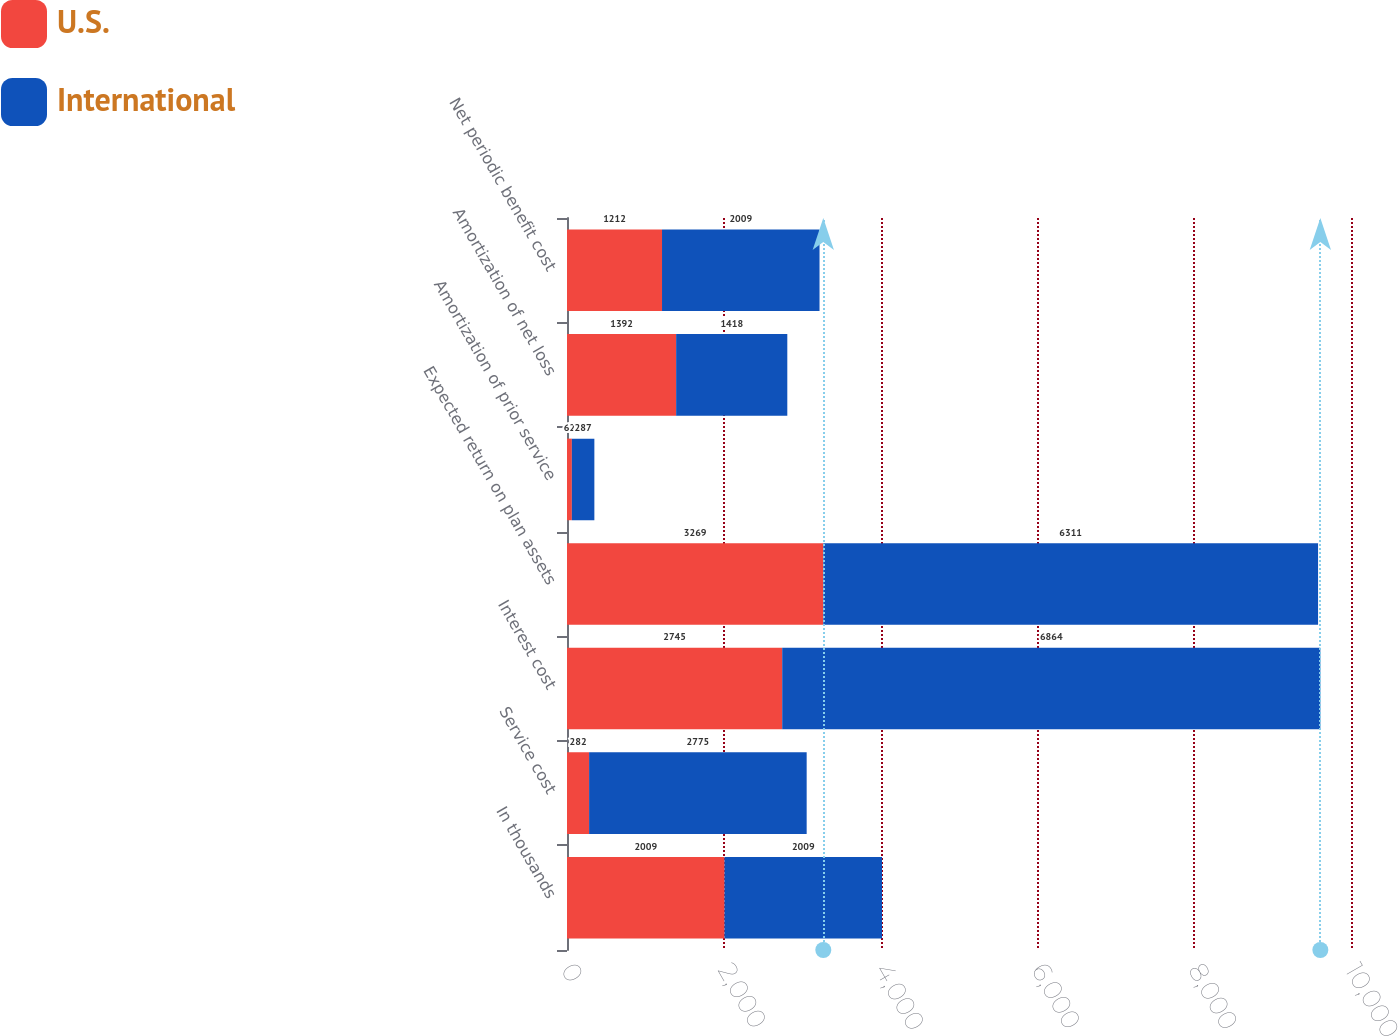Convert chart. <chart><loc_0><loc_0><loc_500><loc_500><stacked_bar_chart><ecel><fcel>In thousands<fcel>Service cost<fcel>Interest cost<fcel>Expected return on plan assets<fcel>Amortization of prior service<fcel>Amortization of net loss<fcel>Net periodic benefit cost<nl><fcel>U.S.<fcel>2009<fcel>282<fcel>2745<fcel>3269<fcel>62<fcel>1392<fcel>1212<nl><fcel>International<fcel>2009<fcel>2775<fcel>6864<fcel>6311<fcel>287<fcel>1418<fcel>2009<nl></chart> 